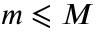<formula> <loc_0><loc_0><loc_500><loc_500>m \leqslant M</formula> 